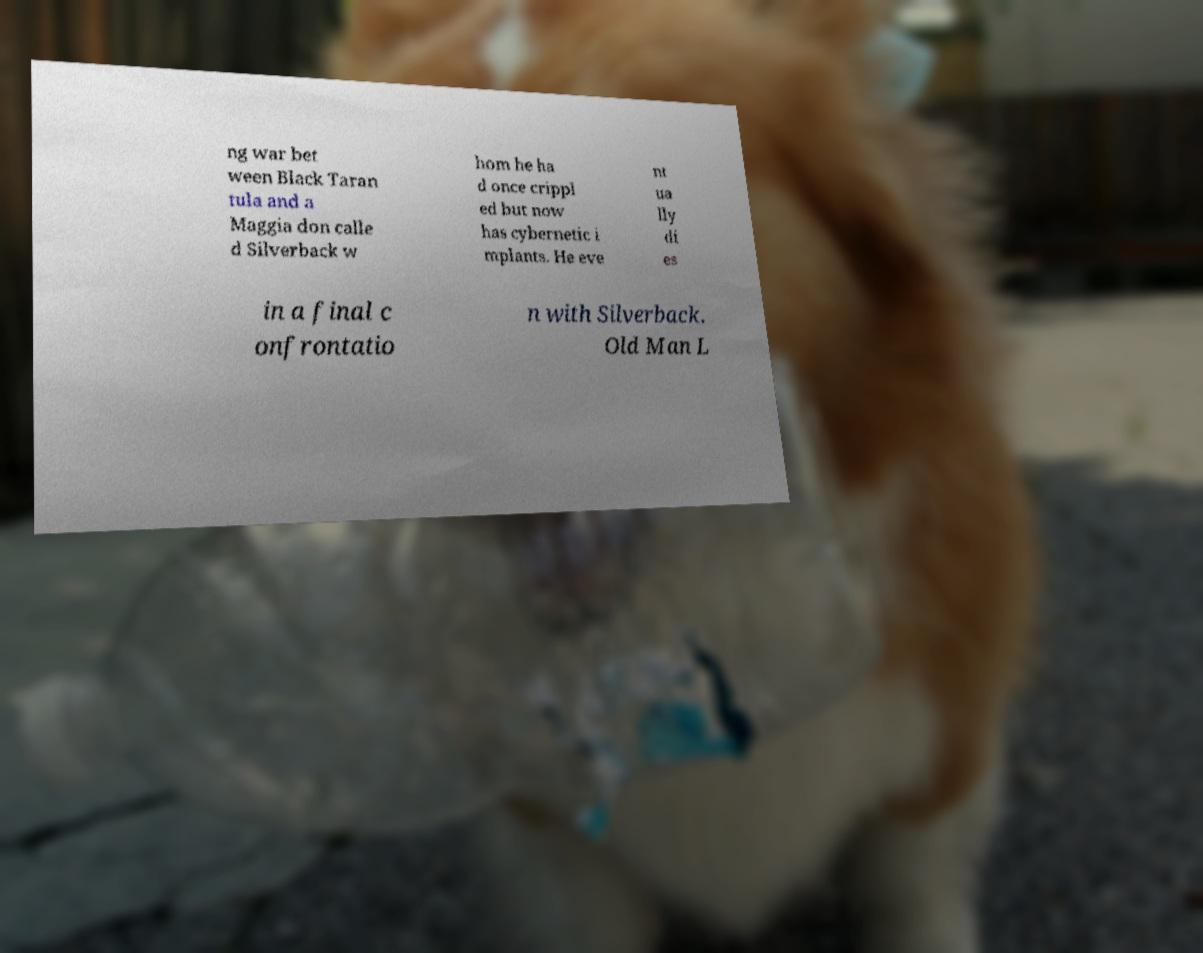There's text embedded in this image that I need extracted. Can you transcribe it verbatim? ng war bet ween Black Taran tula and a Maggia don calle d Silverback w hom he ha d once crippl ed but now has cybernetic i mplants. He eve nt ua lly di es in a final c onfrontatio n with Silverback. Old Man L 